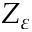Convert formula to latex. <formula><loc_0><loc_0><loc_500><loc_500>Z _ { \varepsilon }</formula> 